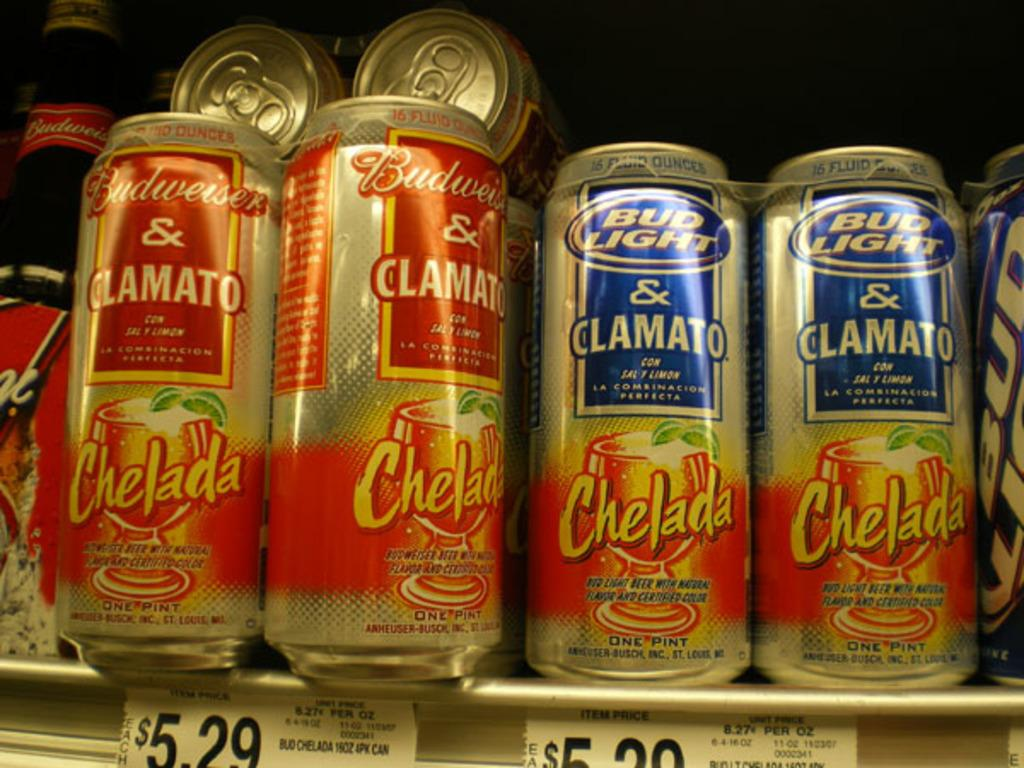<image>
Describe the image concisely. A can of Bud Light & Clamato contains natural flavor and certified color. 